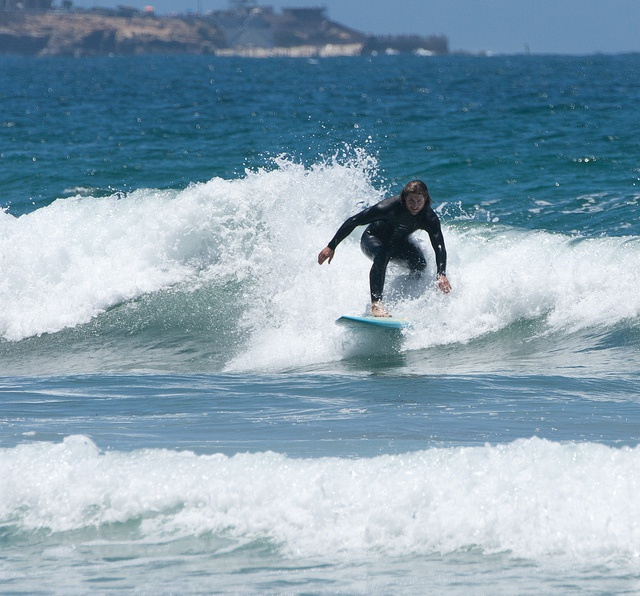Describe the objects in this image and their specific colors. I can see people in gray, black, lightgray, and darkgray tones and surfboard in gray, teal, lightgray, and lightblue tones in this image. 